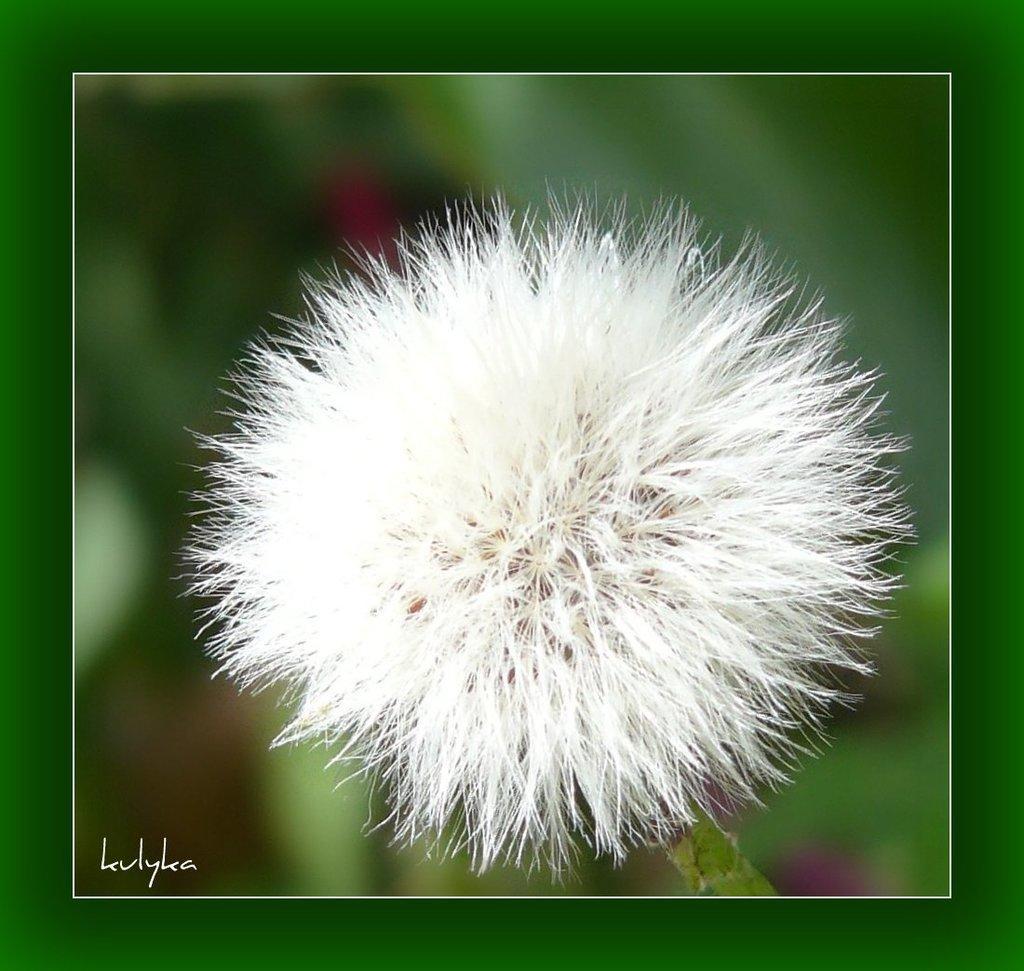Can you describe this image briefly? In this picture we can see a stem with a flower and in the background it is blurry and at the bottom left corner we can see a watermark. 